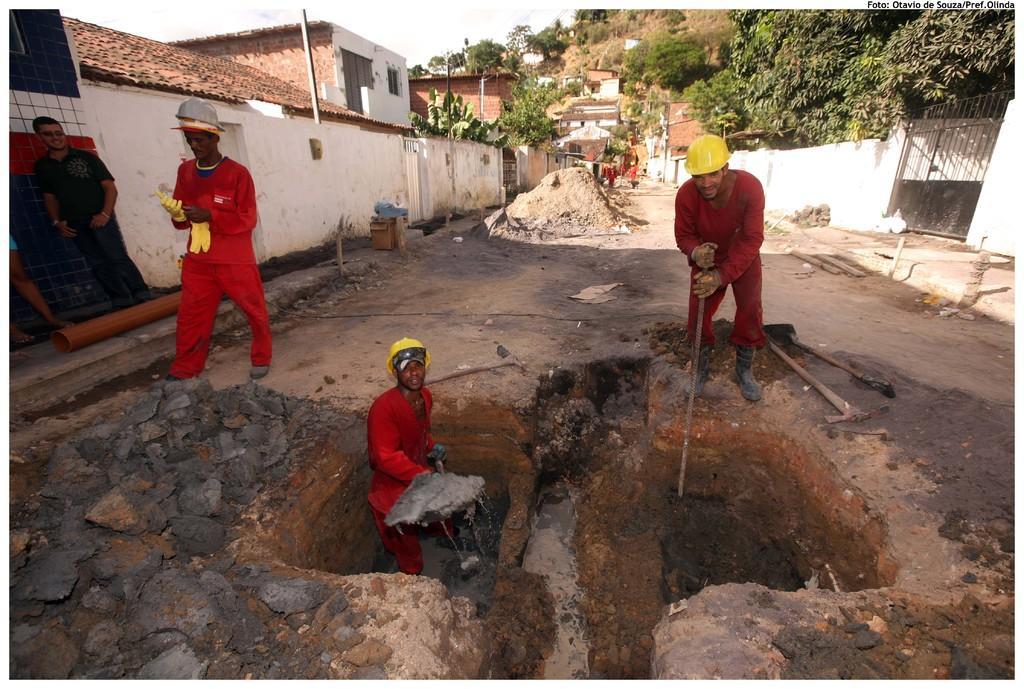How would you summarize this image in a sentence or two? In this image, we can see people wearing clothes. There is a person in the middle of the image holding a tool with his hands. There are roof houses and trees at the top of the image. There is a pipe on the left side of the image. There is a gate in the top right of the image. There are digging tools on the right side of the image. 